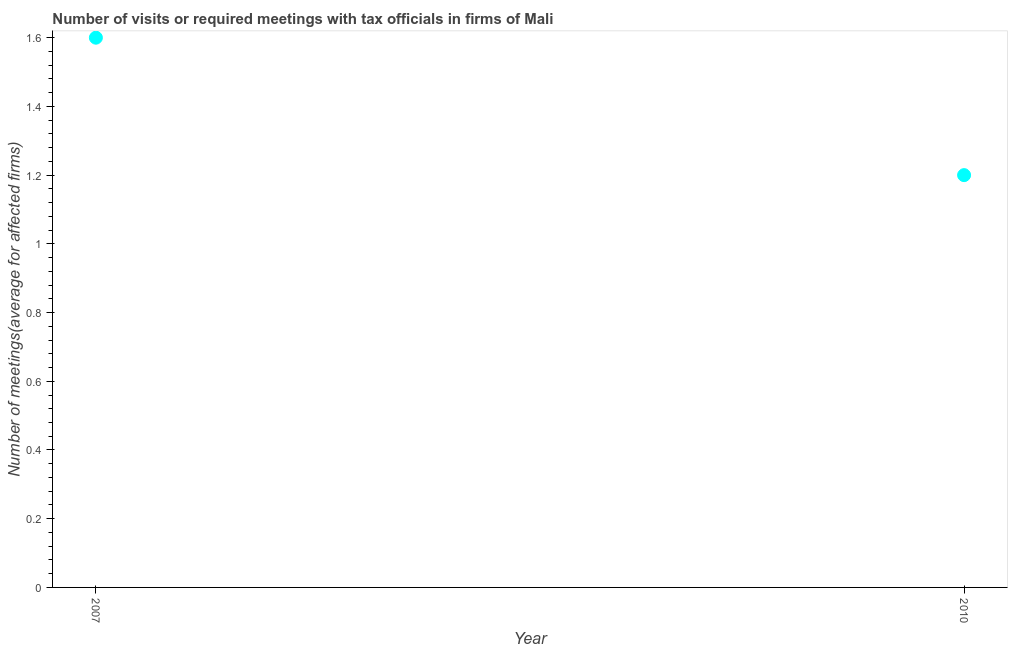What is the number of required meetings with tax officials in 2010?
Offer a very short reply. 1.2. In which year was the number of required meetings with tax officials minimum?
Offer a terse response. 2010. What is the sum of the number of required meetings with tax officials?
Make the answer very short. 2.8. What is the difference between the number of required meetings with tax officials in 2007 and 2010?
Give a very brief answer. 0.4. What is the median number of required meetings with tax officials?
Make the answer very short. 1.4. In how many years, is the number of required meetings with tax officials greater than 1.2800000000000002 ?
Make the answer very short. 1. Do a majority of the years between 2007 and 2010 (inclusive) have number of required meetings with tax officials greater than 0.88 ?
Offer a very short reply. Yes. What is the ratio of the number of required meetings with tax officials in 2007 to that in 2010?
Your answer should be compact. 1.33. In how many years, is the number of required meetings with tax officials greater than the average number of required meetings with tax officials taken over all years?
Your answer should be very brief. 1. How many dotlines are there?
Provide a short and direct response. 1. What is the difference between two consecutive major ticks on the Y-axis?
Your answer should be very brief. 0.2. Does the graph contain any zero values?
Provide a short and direct response. No. What is the title of the graph?
Your answer should be compact. Number of visits or required meetings with tax officials in firms of Mali. What is the label or title of the Y-axis?
Offer a terse response. Number of meetings(average for affected firms). What is the Number of meetings(average for affected firms) in 2010?
Offer a very short reply. 1.2. What is the ratio of the Number of meetings(average for affected firms) in 2007 to that in 2010?
Make the answer very short. 1.33. 